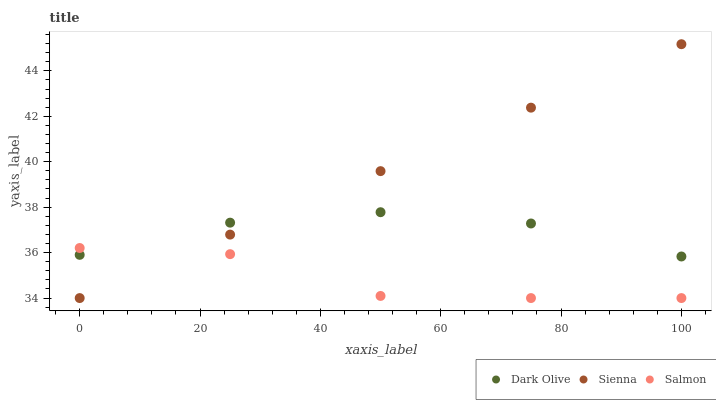Does Salmon have the minimum area under the curve?
Answer yes or no. Yes. Does Sienna have the maximum area under the curve?
Answer yes or no. Yes. Does Dark Olive have the minimum area under the curve?
Answer yes or no. No. Does Dark Olive have the maximum area under the curve?
Answer yes or no. No. Is Sienna the smoothest?
Answer yes or no. Yes. Is Salmon the roughest?
Answer yes or no. Yes. Is Dark Olive the smoothest?
Answer yes or no. No. Is Dark Olive the roughest?
Answer yes or no. No. Does Sienna have the lowest value?
Answer yes or no. Yes. Does Dark Olive have the lowest value?
Answer yes or no. No. Does Sienna have the highest value?
Answer yes or no. Yes. Does Dark Olive have the highest value?
Answer yes or no. No. Does Sienna intersect Dark Olive?
Answer yes or no. Yes. Is Sienna less than Dark Olive?
Answer yes or no. No. Is Sienna greater than Dark Olive?
Answer yes or no. No. 